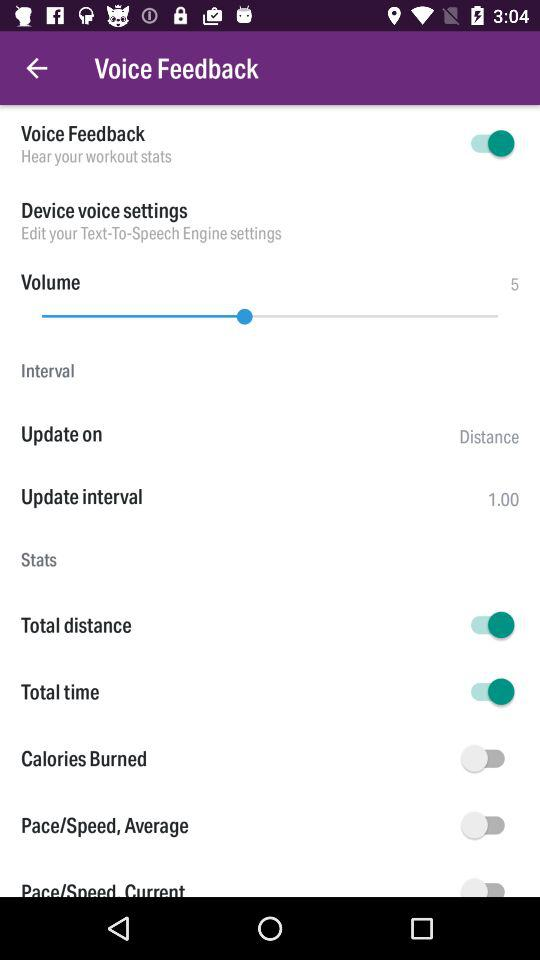What is the status of the "Total time"? The status is on. 